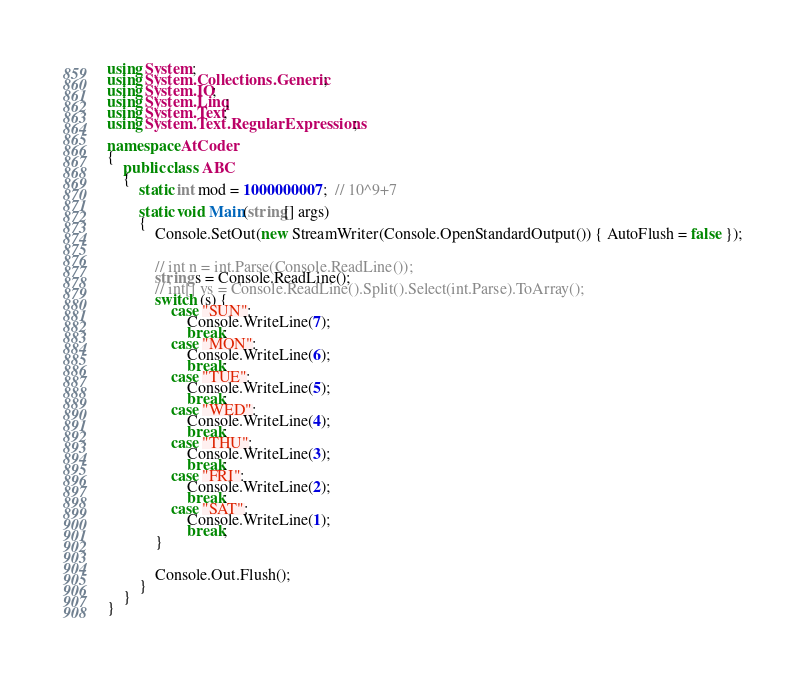<code> <loc_0><loc_0><loc_500><loc_500><_C#_>using System;
using System.Collections.Generic;
using System.IO;
using System.Linq;
using System.Text;
using System.Text.RegularExpressions;

namespace AtCoder
{
	public class ABC
	{
		static int mod = 1000000007;  // 10^9+7

		static void Main(string[] args)
		{
			Console.SetOut(new StreamWriter(Console.OpenStandardOutput()) { AutoFlush = false });


			// int n = int.Parse(Console.ReadLine());
			string s = Console.ReadLine();
			// int[] vs = Console.ReadLine().Split().Select(int.Parse).ToArray();
			switch (s) {
				case "SUN":
					Console.WriteLine(7);
					break;
				case "MON":
					Console.WriteLine(6);
					break;
				case "TUE":
					Console.WriteLine(5);
					break;
				case "WED":
					Console.WriteLine(4);
					break;
				case "THU":
					Console.WriteLine(3);
					break;
				case "FRI":
					Console.WriteLine(2);
					break;
				case "SAT":
					Console.WriteLine(1);
					break;
			}


			Console.Out.Flush();
		}
	}
}
</code> 